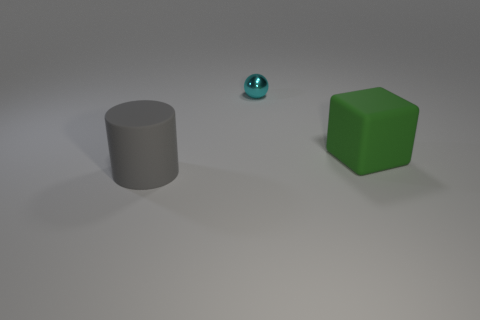Are there fewer big matte cubes in front of the large gray cylinder than small green spheres?
Provide a succinct answer. No. Do the big matte thing that is left of the big block and the small metallic thing have the same shape?
Your response must be concise. No. Are there any other things of the same color as the large cube?
Ensure brevity in your answer.  No. What is the object in front of the big thing that is on the right side of the big thing on the left side of the large green rubber cube made of?
Offer a very short reply. Rubber. Are there fewer big gray cylinders than large cyan cubes?
Offer a terse response. No. Is the cylinder made of the same material as the cyan thing?
Make the answer very short. No. There is a large thing that is right of the cylinder; what number of cylinders are in front of it?
Your response must be concise. 1. There is another object that is the same size as the green thing; what is its color?
Your response must be concise. Gray. What material is the thing behind the big rubber cube?
Provide a short and direct response. Metal. There is a thing that is left of the green block and in front of the ball; what material is it?
Offer a terse response. Rubber. 